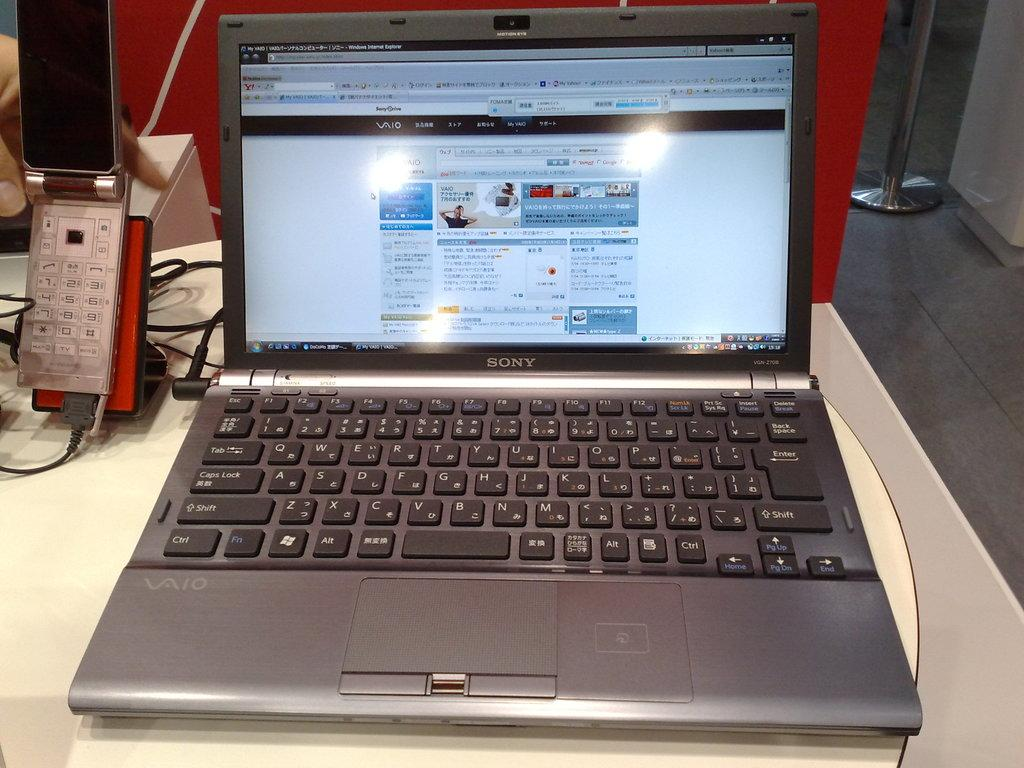Provide a one-sentence caption for the provided image. a Sony lap top computer open to show a display of colorful images. 